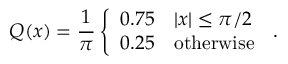<formula> <loc_0><loc_0><loc_500><loc_500>Q ( x ) = \frac { 1 } { \pi } \left \{ \begin{array} { l l } { 0 . 7 5 \quad | x | \leq \pi / 2 } \\ { 0 . 2 5 \quad o t h e r w i s e } \end{array} \, .</formula> 